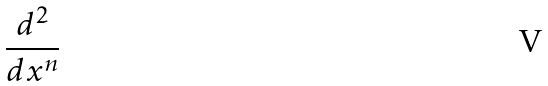<formula> <loc_0><loc_0><loc_500><loc_500>\frac { d ^ { 2 } } { d x ^ { n } }</formula> 